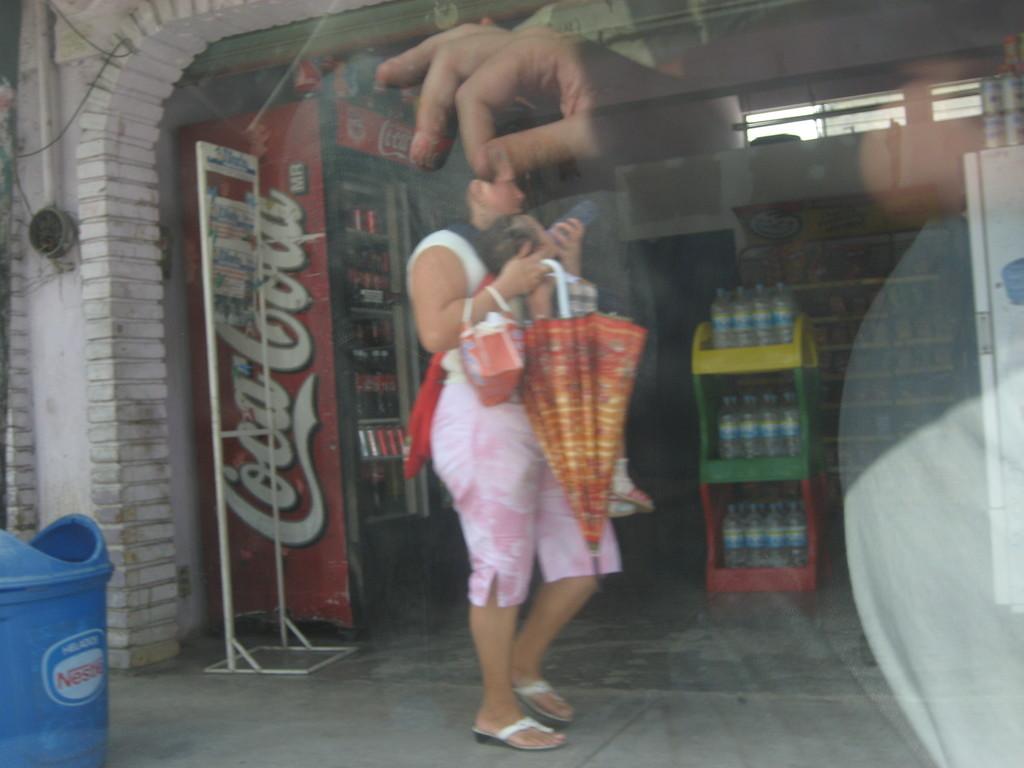What drink is on the fridge?
Give a very brief answer. Coca cola. Who is advertised on the trash can?
Your answer should be compact. Nestle. 